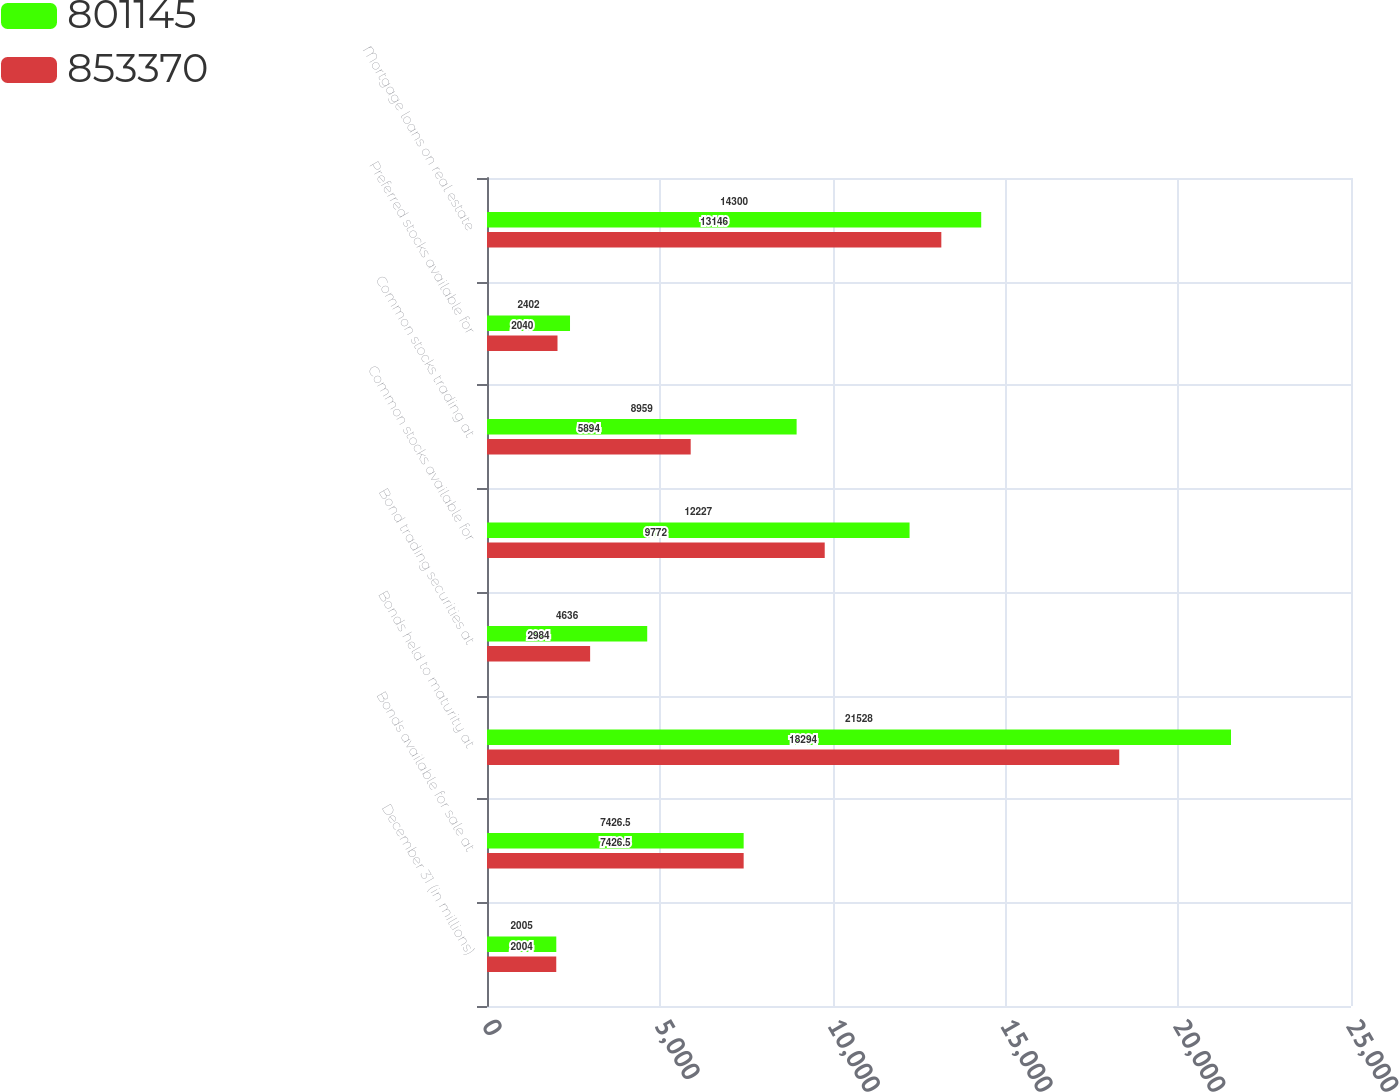Convert chart. <chart><loc_0><loc_0><loc_500><loc_500><stacked_bar_chart><ecel><fcel>December 31 (in millions)<fcel>Bonds available for sale at<fcel>Bonds held to maturity at<fcel>Bond trading securities at<fcel>Common stocks available for<fcel>Common stocks trading at<fcel>Preferred stocks available for<fcel>Mortgage loans on real estate<nl><fcel>801145<fcel>2005<fcel>7426.5<fcel>21528<fcel>4636<fcel>12227<fcel>8959<fcel>2402<fcel>14300<nl><fcel>853370<fcel>2004<fcel>7426.5<fcel>18294<fcel>2984<fcel>9772<fcel>5894<fcel>2040<fcel>13146<nl></chart> 